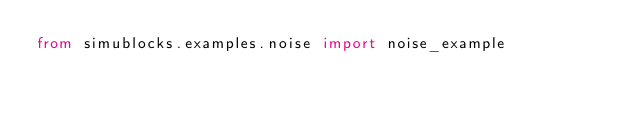<code> <loc_0><loc_0><loc_500><loc_500><_Python_>from simublocks.examples.noise import noise_example</code> 